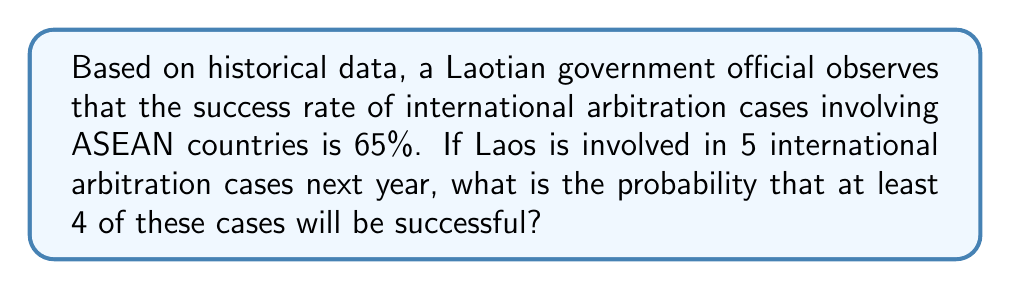What is the answer to this math problem? Let's approach this step-by-step using the binomial probability distribution:

1) We can model this scenario as a binomial distribution with:
   $n = 5$ (number of trials/cases)
   $p = 0.65$ (probability of success for each case)
   $X$ = number of successful cases

2) We need to find $P(X \geq 4)$, which is equivalent to $P(X=4) + P(X=5)$

3) The binomial probability formula is:
   $$P(X = k) = \binom{n}{k} p^k (1-p)^{n-k}$$

4) For $P(X = 4)$:
   $$P(X = 4) = \binom{5}{4} (0.65)^4 (0.35)^1$$
   $$= 5 \cdot (0.65)^4 \cdot (0.35)$$
   $$= 5 \cdot 0.178746 \cdot 0.35$$
   $$= 0.312805$$

5) For $P(X = 5)$:
   $$P(X = 5) = \binom{5}{5} (0.65)^5 (0.35)^0$$
   $$= 1 \cdot (0.65)^5 \cdot 1$$
   $$= 0.116185$$

6) Therefore, $P(X \geq 4) = P(X = 4) + P(X = 5)$
   $$= 0.312805 + 0.116185 = 0.42899$$
Answer: 0.42899 